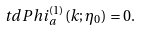Convert formula to latex. <formula><loc_0><loc_0><loc_500><loc_500>\ t d P h i _ { a } ^ { ( 1 ) } ( k ; \eta _ { 0 } ) = 0 .</formula> 